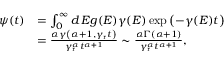Convert formula to latex. <formula><loc_0><loc_0><loc_500><loc_500>\begin{array} { r l } { \psi ( t ) } & { = \int _ { 0 } ^ { \infty } d \, E g ( E ) \gamma ( E ) \exp \left ( - \gamma ( E ) t \right ) } \\ & { = \frac { \alpha \gamma \left ( \alpha + 1 , \gamma _ { r } t \right ) } { \gamma _ { r } ^ { \alpha } t ^ { \alpha + 1 } } \sim \frac { \alpha \Gamma \left ( \alpha + 1 \right ) } { \gamma _ { r } ^ { \alpha } t ^ { \alpha + 1 } } , } \end{array}</formula> 